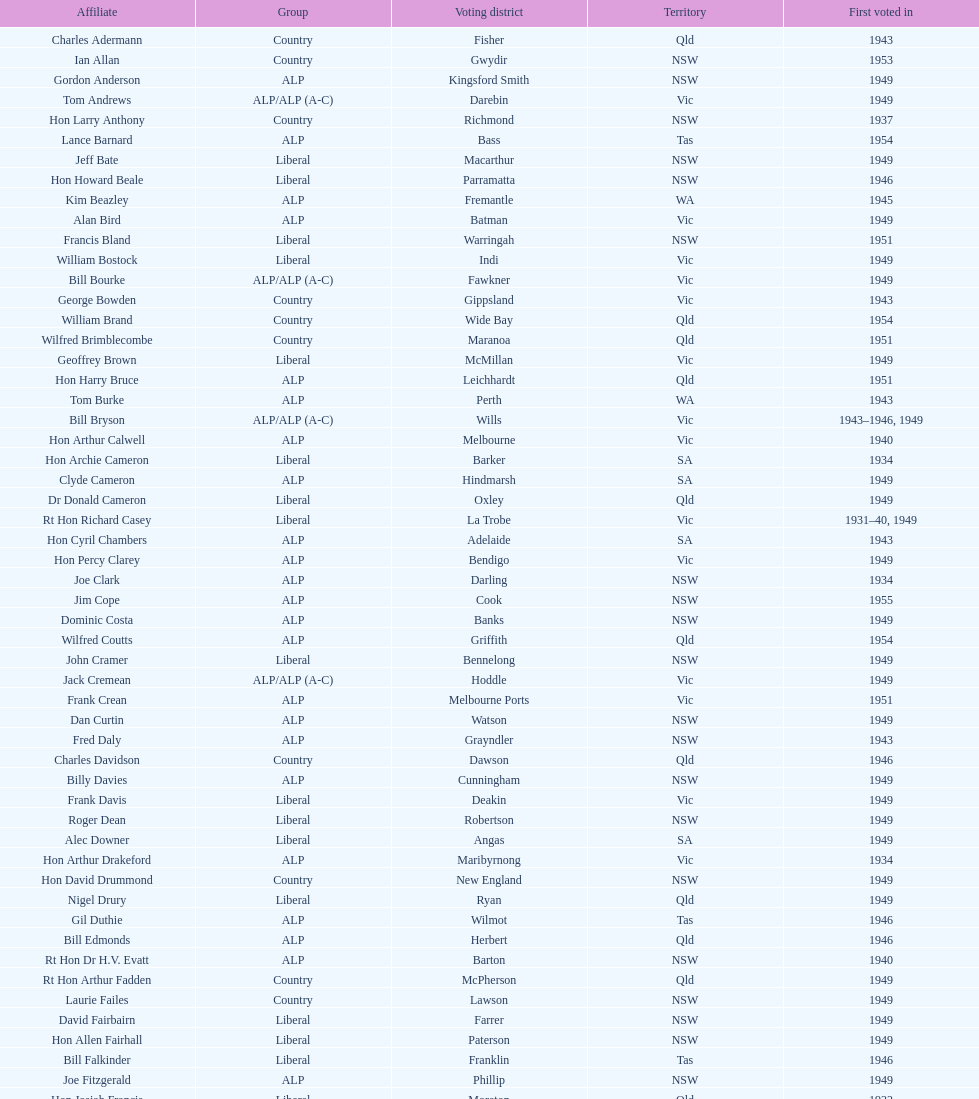Which party was elected the least? Country. 